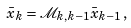Convert formula to latex. <formula><loc_0><loc_0><loc_500><loc_500>\bar { x } _ { k } = \mathcal { M } _ { k , k - 1 } \bar { x } _ { k - 1 } \, ,</formula> 